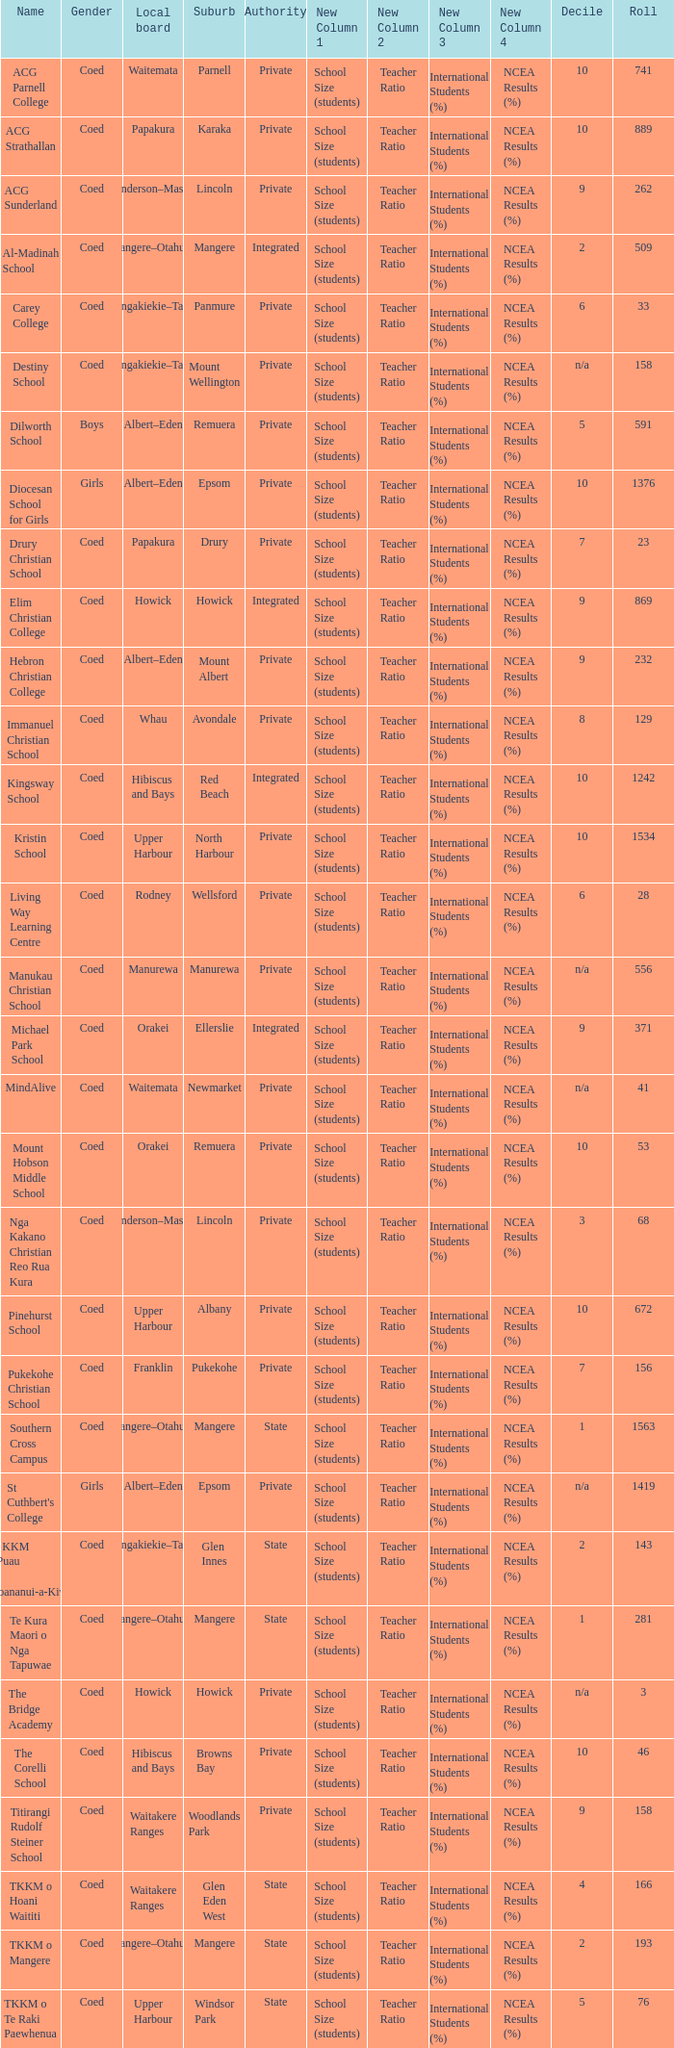What is the name of the suburb with a roll of 741? Parnell. 